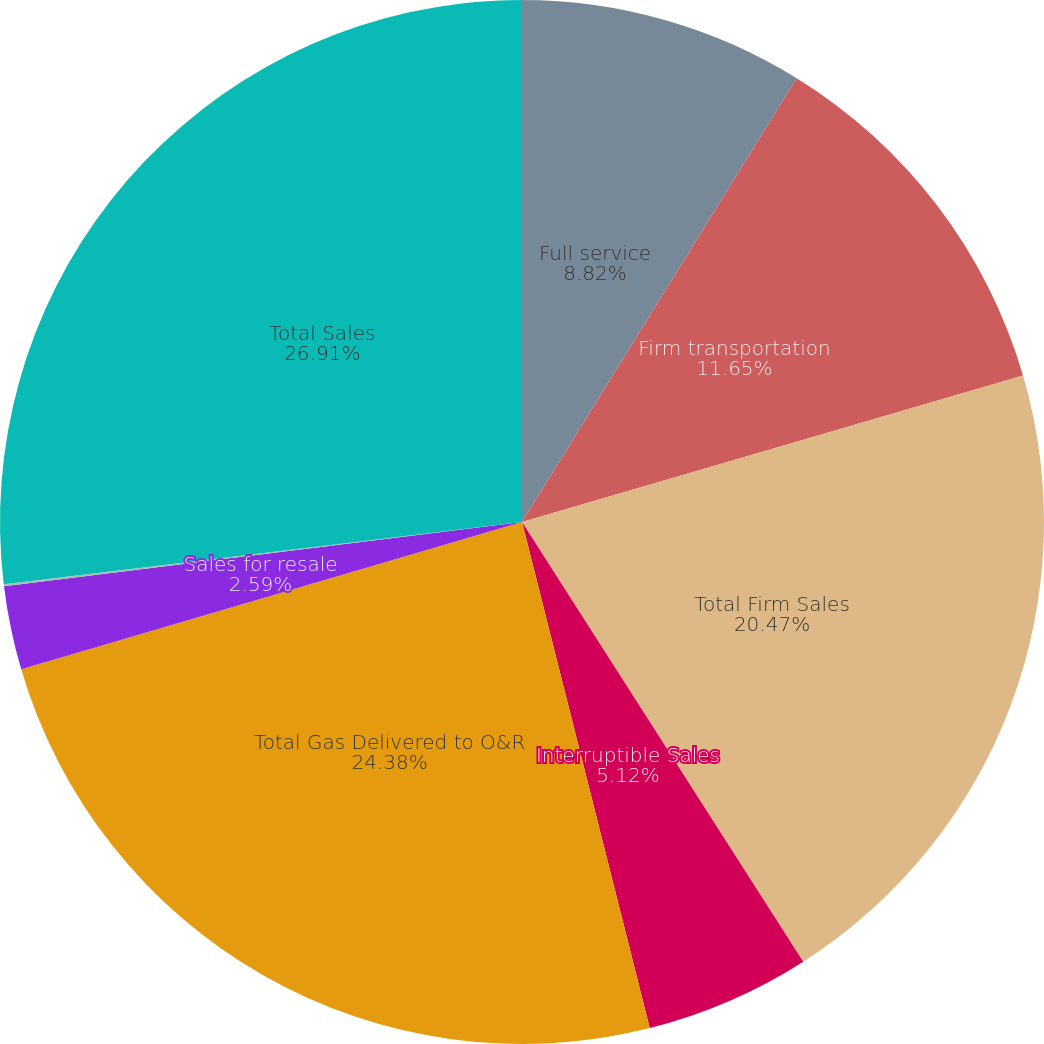<chart> <loc_0><loc_0><loc_500><loc_500><pie_chart><fcel>Full service<fcel>Firm transportation<fcel>Total Firm Sales<fcel>Interruptible Sales<fcel>Total Gas Delivered to O&R<fcel>Sales for resale<fcel>Sales to electric generating<fcel>Total Sales<nl><fcel>8.82%<fcel>11.65%<fcel>20.47%<fcel>5.12%<fcel>24.38%<fcel>2.59%<fcel>0.06%<fcel>26.9%<nl></chart> 